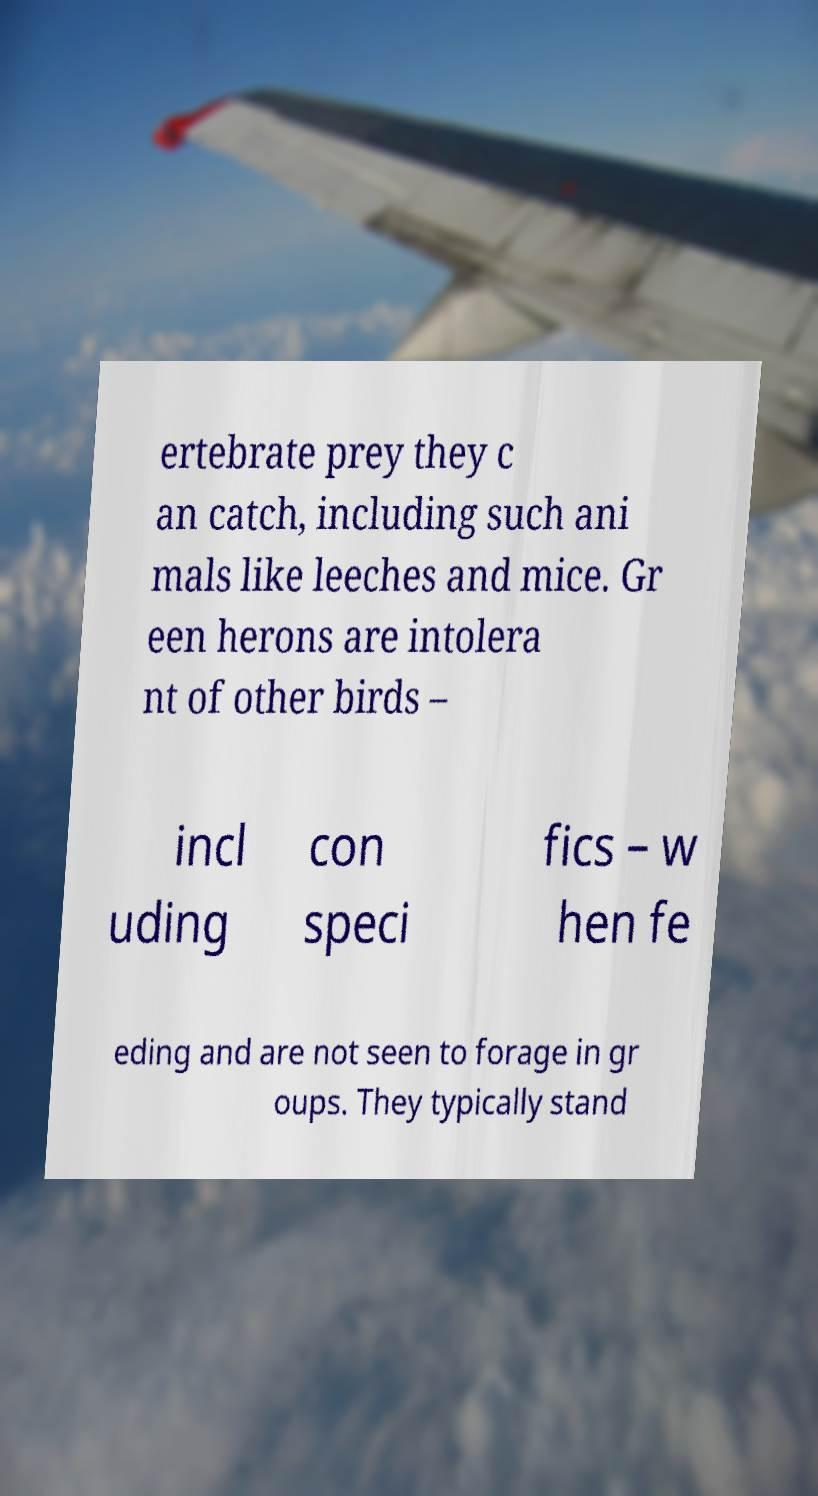What messages or text are displayed in this image? I need them in a readable, typed format. ertebrate prey they c an catch, including such ani mals like leeches and mice. Gr een herons are intolera nt of other birds – incl uding con speci fics – w hen fe eding and are not seen to forage in gr oups. They typically stand 